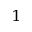<formula> <loc_0><loc_0><loc_500><loc_500>^ { 1 }</formula> 